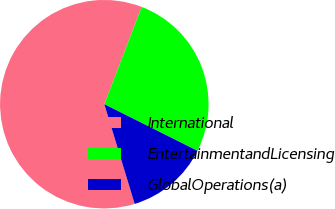<chart> <loc_0><loc_0><loc_500><loc_500><pie_chart><fcel>International<fcel>EntertainmentandLicensing<fcel>GlobalOperations(a)<nl><fcel>60.54%<fcel>26.55%<fcel>12.91%<nl></chart> 